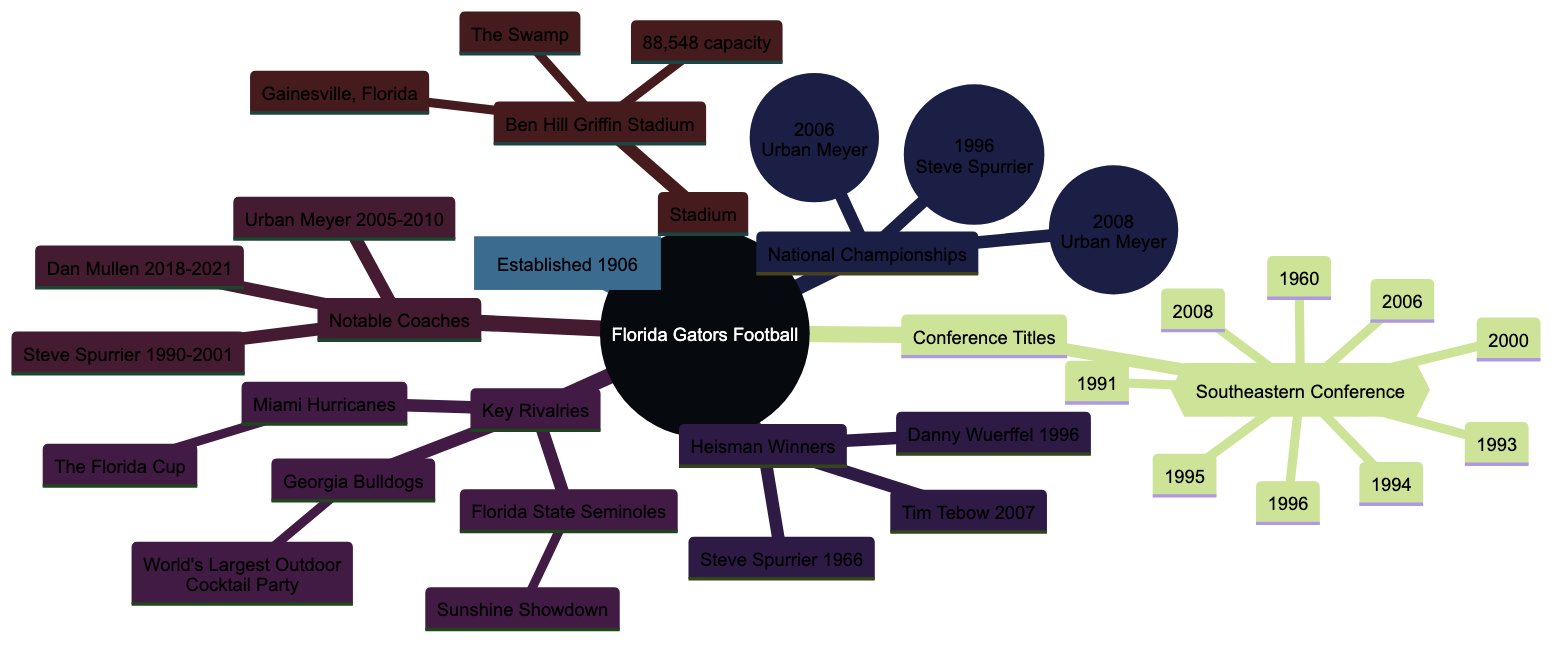What year was the Florida Gators football program established? The diagram states that the Florida Gators football program was established in 1906. This information is directly presented in the "Established" node of the diagram.
Answer: 1906 How many National Championships have the Florida Gators won? From the "National Championships" section of the diagram, there are three specific years listed (1996, 2006, 2008) where they won championships. Therefore, counting these entries shows that they have won three National Championships.
Answer: 3 Who was the coach during the Florida Gators' National Championship win in 1996? The diagram lists the year 1996 under National Championships and specifies that the coach at that time was Steve Spurrier. This information is connected directly to the year's node.
Answer: Steve Spurrier What is the nickname of the Florida Gators' stadium? The diagram specifies in the "Stadium" section that the name of the stadium is Ben Hill Griffin Stadium, and it also includes the nickname "The Swamp". This nickname is a direct reference within that section.
Answer: The Swamp Which two coaches had a tenure that overlapped in the years 2005 to 2010? Referring to the "Notable Coaches" section, Urban Meyer is noted to have a tenure from 2005 to 2010. The previous coach, Steve Spurrier, had completed his tenure in 2001, which means there is no overlap. Therefore, only one coach is present during the 2005 to 2010 period.
Answer: Urban Meyer What is the capacity of the Florida Gators' stadium? The "Stadium" section of the diagram states that Ben Hill Griffin Stadium has a capacity of 88,548. This number is specifically indicated next to the stadium details.
Answer: 88,548 How many key rival teams are listed in the diagram? The "Key Rivalries" section enumerates three teams (Miami Hurricanes, Georgia Bulldogs, Florida State Seminoles) with associated nicknames. Thus, the count of key rival teams sums up to three.
Answer: 3 Which Heisman winner played for the Florida Gators in 2007? The "Heisman Winners" node shows a list of players and years. Tim Tebow is explicitly listed as the Heisman winner for the year 2007, making it clear who the winner was for that year.
Answer: Tim Tebow What was the nickname for the Florida Gators' rivalry with the Georgia Bulldogs? Under "Key Rivalries", the rivalry with the Georgia Bulldogs is noted specifically as "The World's Largest Outdoor Cocktail Party". This nickname directly corresponds to the rivalry mentioned.
Answer: The World's Largest Outdoor Cocktail Party 